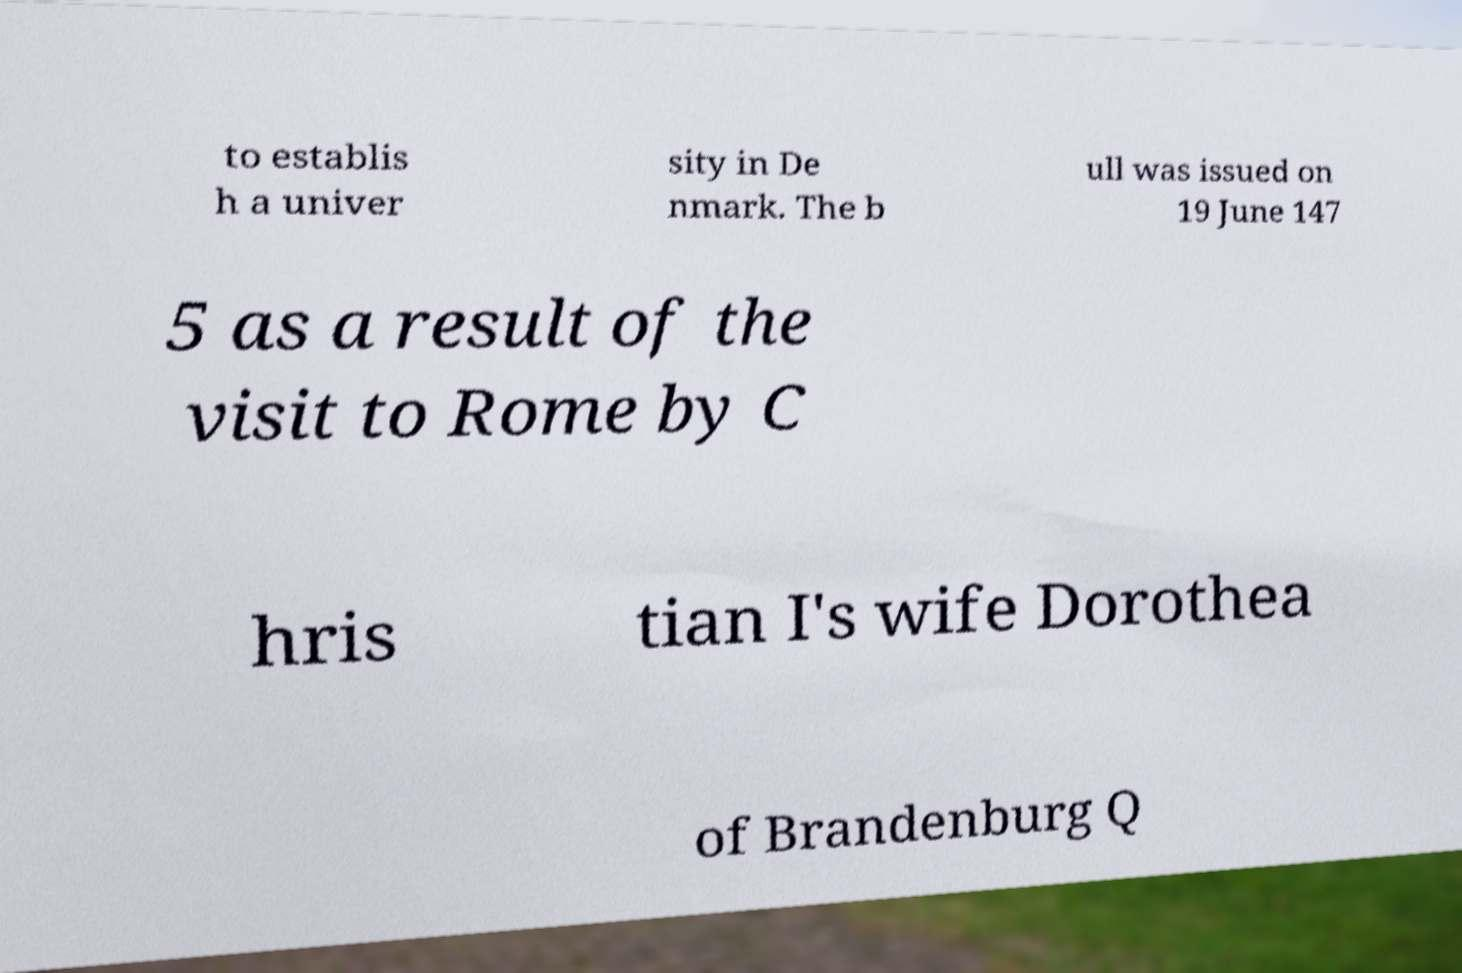Please read and relay the text visible in this image. What does it say? to establis h a univer sity in De nmark. The b ull was issued on 19 June 147 5 as a result of the visit to Rome by C hris tian I's wife Dorothea of Brandenburg Q 